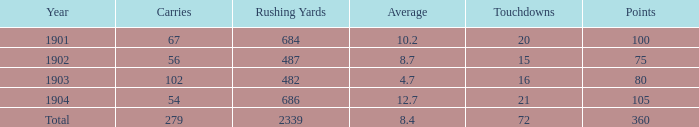How many carries are connected with 80 points and under 16 touchdowns? None. 